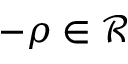Convert formula to latex. <formula><loc_0><loc_0><loc_500><loc_500>- \rho \in \mathcal { R }</formula> 